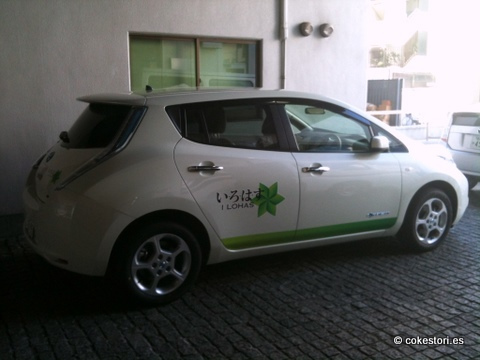<image>
Is the car on the building? No. The car is not positioned on the building. They may be near each other, but the car is not supported by or resting on top of the building. 